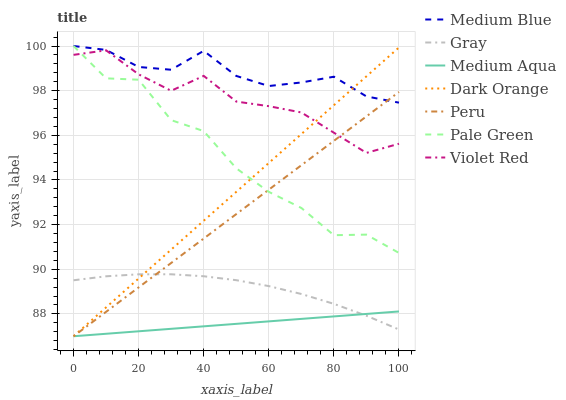Does Violet Red have the minimum area under the curve?
Answer yes or no. No. Does Violet Red have the maximum area under the curve?
Answer yes or no. No. Is Violet Red the smoothest?
Answer yes or no. No. Is Violet Red the roughest?
Answer yes or no. No. Does Violet Red have the lowest value?
Answer yes or no. No. Does Violet Red have the highest value?
Answer yes or no. No. Is Medium Aqua less than Medium Blue?
Answer yes or no. Yes. Is Medium Blue greater than Violet Red?
Answer yes or no. Yes. Does Medium Aqua intersect Medium Blue?
Answer yes or no. No. 